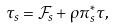Convert formula to latex. <formula><loc_0><loc_0><loc_500><loc_500>& \tau _ { s } = \mathcal { F } _ { s } + \rho \pi ^ { * } _ { s } \tau ,</formula> 